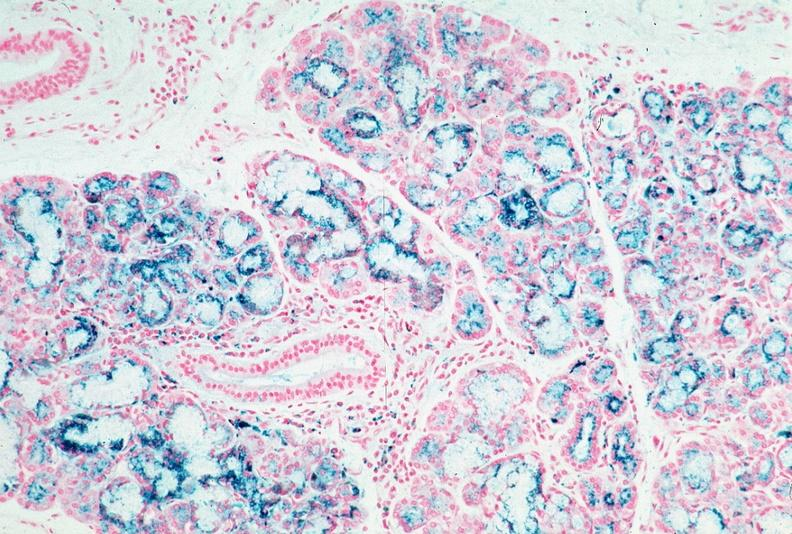where is this?
Answer the question using a single word or phrase. Pancreas 